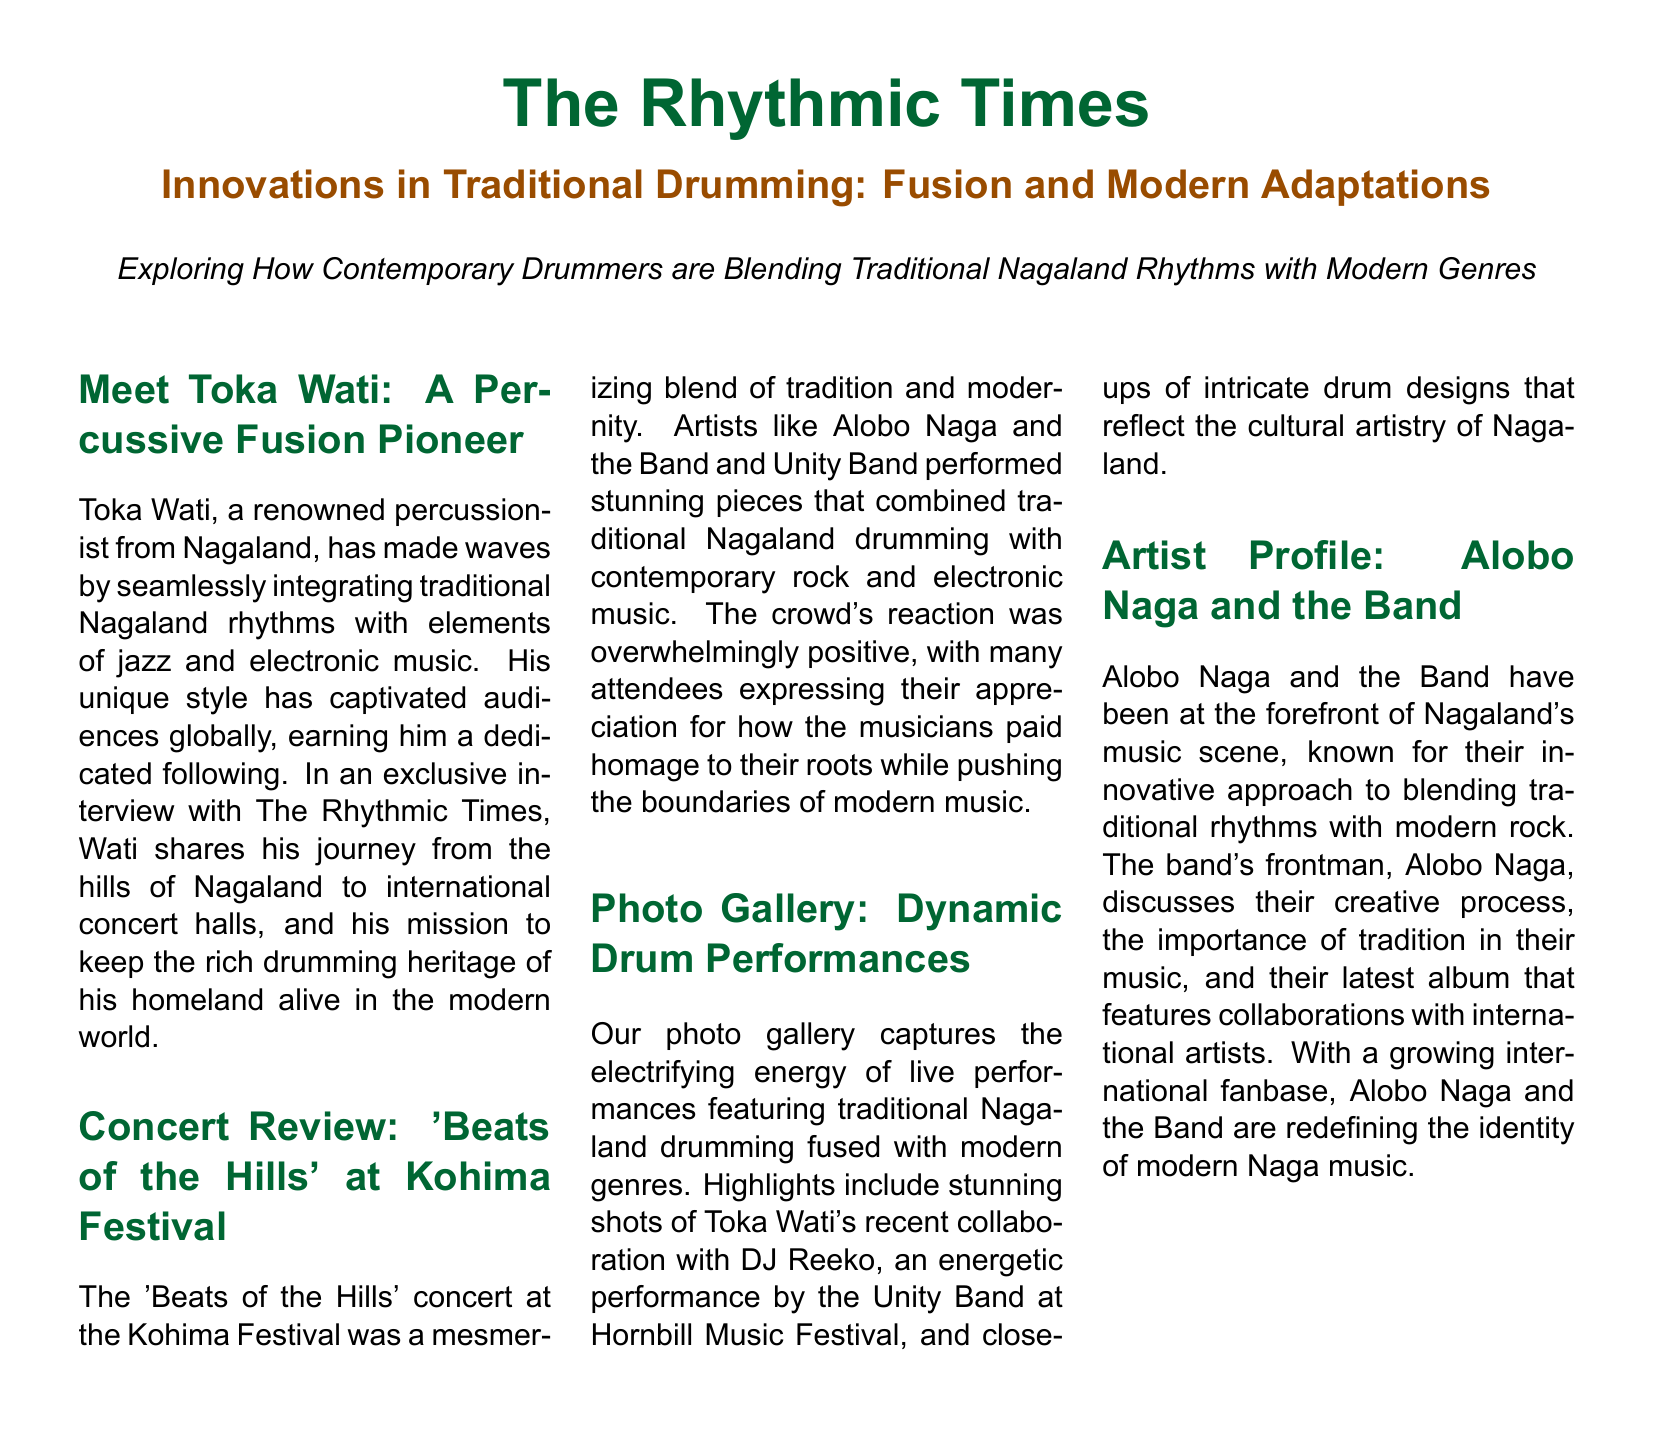What is the title of the article? The title of the article is prominently featured in the document and is "Innovations in Traditional Drumming: Fusion and Modern Adaptations."
Answer: Innovations in Traditional Drumming: Fusion and Modern Adaptations Who is the percussionist mentioned as a pioneer in fusion? Toka Wati is highlighted as a renowned percussionist who seamlessly integrates traditional rhythms with modern elements.
Answer: Toka Wati What concert is reviewed in the document? The concert reviewed is titled 'Beats of the Hills' and took place at the Kohima Festival.
Answer: Beats of the Hills Which band is known for blending traditional rhythms with modern rock? Alobo Naga and the Band are specifically mentioned for their innovative blending of traditional rhythms and modern rock.
Answer: Alobo Naga and the Band Who performed alongside Toka Wati in a recent collaboration? Toka Wati collaborated with DJ Reeko for an energetic performance captured in the photo gallery.
Answer: DJ Reeko What was the audience's reaction to the 'Beats of the Hills' concert? The crowd's reaction was overwhelmingly positive, indicating strong appreciation for the musicians' performance.
Answer: Overwhelmingly positive How many columns are used in the document layout? The document is organized into three columns for presenting information about various artists and events.
Answer: Three In which festival did the Unity Band perform? The Unity Band performed at the Hornbill Music Festival, as noted in the photo gallery section.
Answer: Hornbill Music Festival What does Alobo Naga discuss in his artist profile? Alobo Naga discusses their creative process, the importance of tradition, and their latest album featuring collaborations with international artists.
Answer: Creative process, importance of tradition, latest album What color is used for section titles in the document? The section titles are presented in a specific color defined in the document as "nagaland."
Answer: Nagaland 